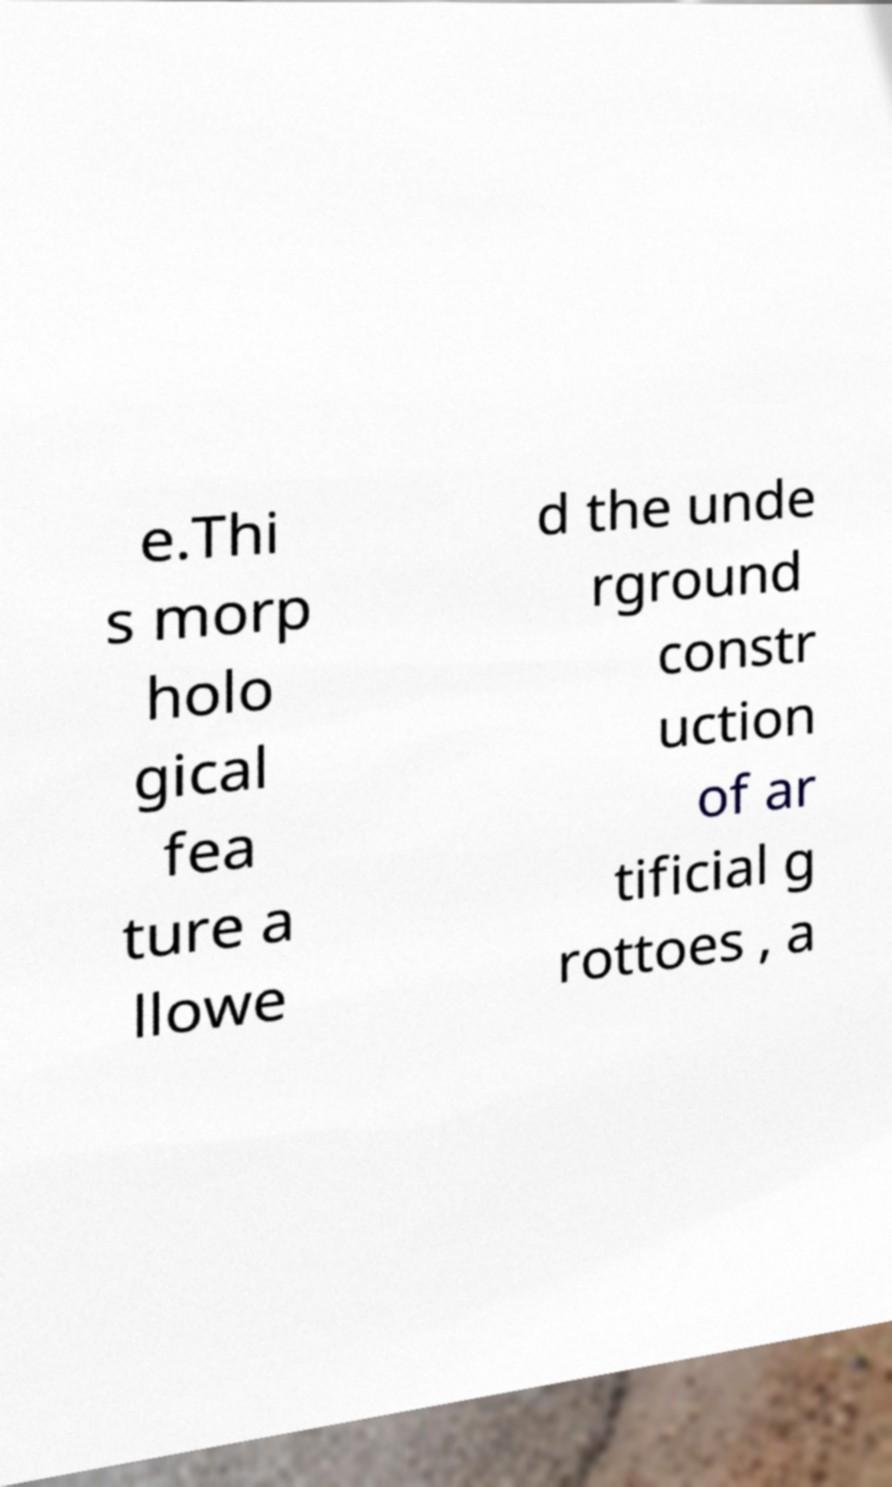There's text embedded in this image that I need extracted. Can you transcribe it verbatim? e.Thi s morp holo gical fea ture a llowe d the unde rground constr uction of ar tificial g rottoes , a 